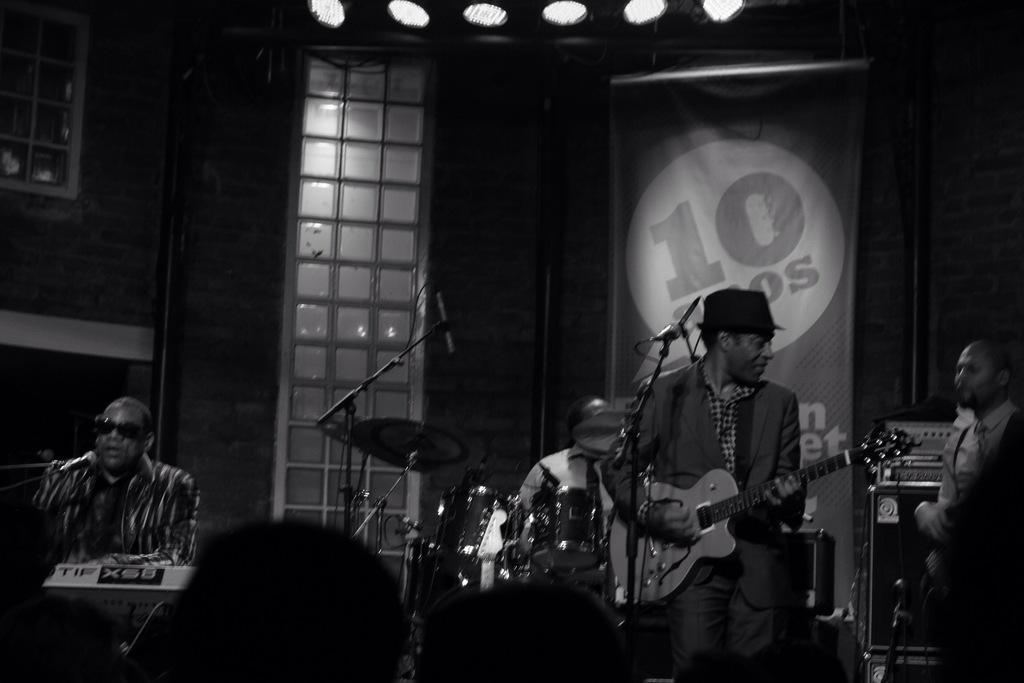Could you give a brief overview of what you see in this image? There are four persons playing music in front of the audience. 